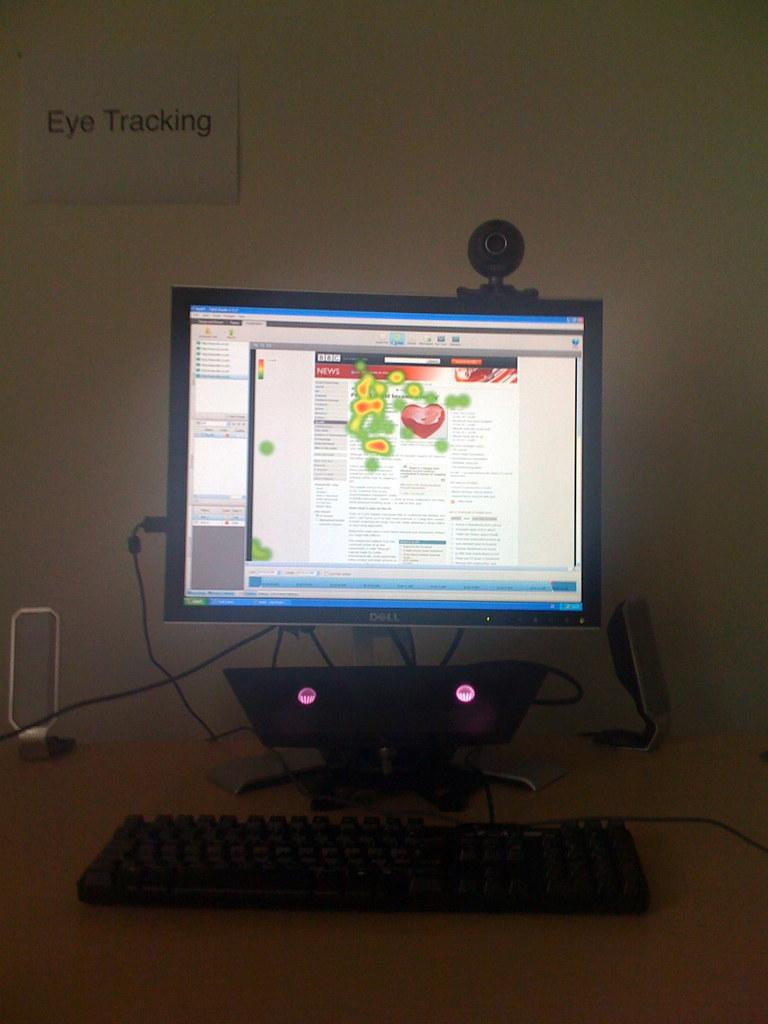What does the sign on the wall say?
Provide a succinct answer. Eye tracking. 